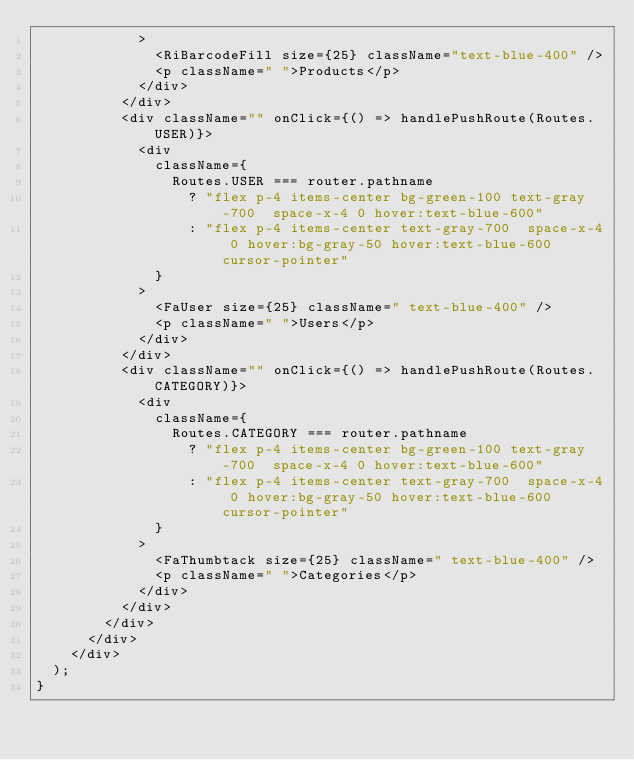<code> <loc_0><loc_0><loc_500><loc_500><_TypeScript_>            >
              <RiBarcodeFill size={25} className="text-blue-400" />
              <p className=" ">Products</p>
            </div>
          </div>
          <div className="" onClick={() => handlePushRoute(Routes.USER)}>
            <div
              className={
                Routes.USER === router.pathname
                  ? "flex p-4 items-center bg-green-100 text-gray-700  space-x-4 0 hover:text-blue-600"
                  : "flex p-4 items-center text-gray-700  space-x-4 0 hover:bg-gray-50 hover:text-blue-600  cursor-pointer"
              }
            >
              <FaUser size={25} className=" text-blue-400" />
              <p className=" ">Users</p>
            </div>
          </div>
          <div className="" onClick={() => handlePushRoute(Routes.CATEGORY)}>
            <div
              className={
                Routes.CATEGORY === router.pathname
                  ? "flex p-4 items-center bg-green-100 text-gray-700  space-x-4 0 hover:text-blue-600"
                  : "flex p-4 items-center text-gray-700  space-x-4 0 hover:bg-gray-50 hover:text-blue-600  cursor-pointer"
              }
            >
              <FaThumbtack size={25} className=" text-blue-400" />
              <p className=" ">Categories</p>
            </div>
          </div>
        </div>
      </div>
    </div>
  );
}
</code> 